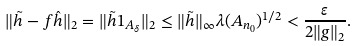Convert formula to latex. <formula><loc_0><loc_0><loc_500><loc_500>\| \tilde { h } - f \hat { h } \| _ { 2 } = \| \tilde { h } 1 _ { A _ { \delta } } \| _ { 2 } \leq \| \tilde { h } \| _ { \infty } \lambda ( A _ { n _ { 0 } } ) ^ { 1 / 2 } < \frac { \varepsilon } { 2 \| g \| _ { 2 } } .</formula> 